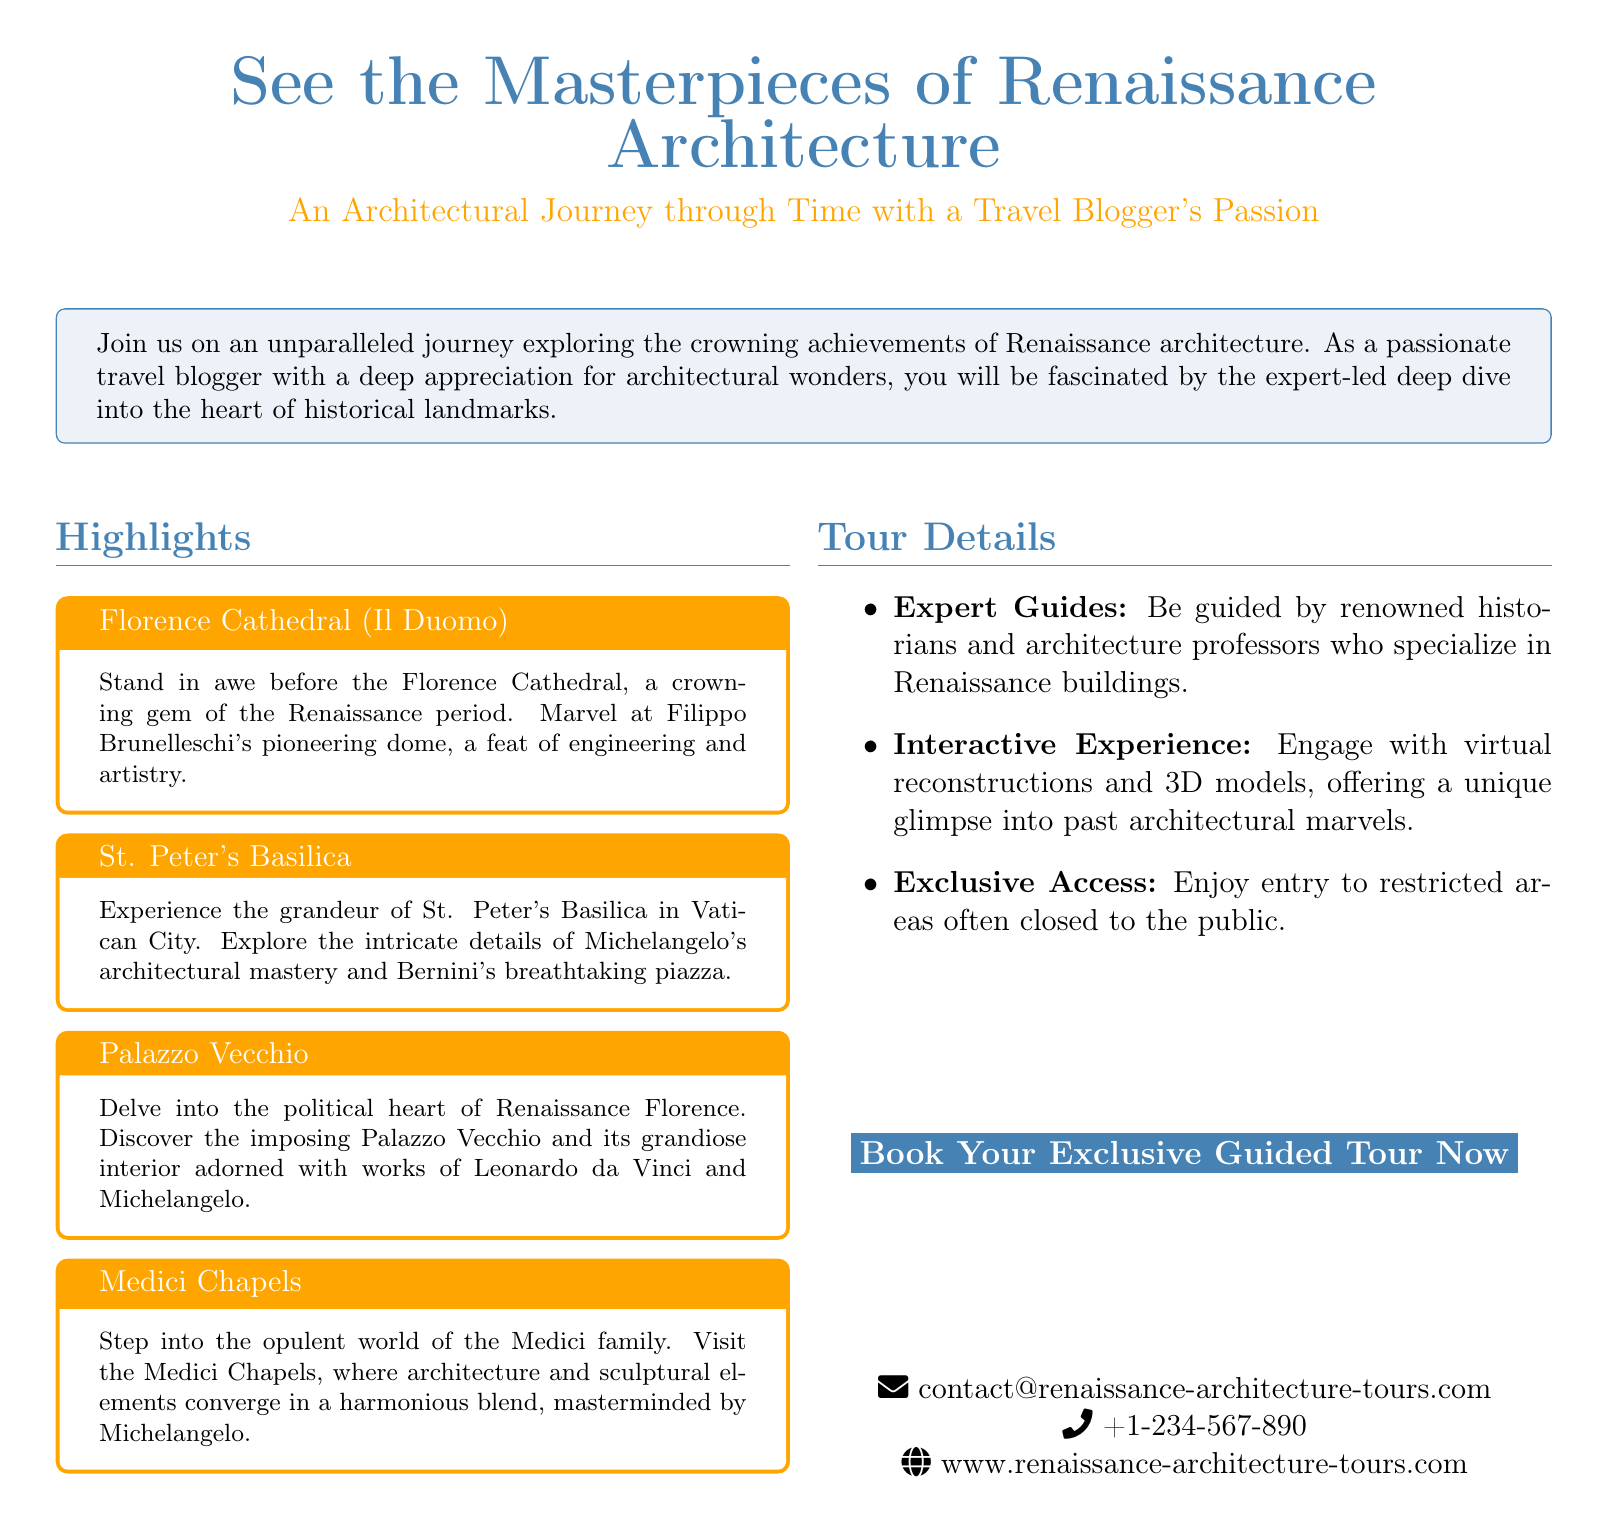What is the title of the event? The title of the event is prominently displayed at the top of the document.
Answer: See the Masterpieces of Renaissance Architecture What city features the Florence Cathedral? The Florence Cathedral is a key highlight mentioned in the document.
Answer: Florence Who designed the dome of the Florence Cathedral? The document attributes the design of the dome to a specific architect.
Answer: Filippo Brunelleschi Which basilica is described in the document? The document specifically names a notable basilica and its location.
Answer: St. Peter's Basilica What is the contact phone number? The document includes a contact number at the bottom.
Answer: +1-234-567-890 What type of experience does the tour offer? The document describes the nature of the tour experience provided.
Answer: Interactive Experience What is featured at the Medici Chapels? The document specifies a unique aspect found at the Medici Chapels.
Answer: Sculpture elements Who guides the tour? The document mentions the type of specialists leading the tours.
Answer: Historians and architecture professors What is one feature of the Palazzo Vecchio? The document highlights a notable aspect of the Palazzo Vecchio's interior.
Answer: Works of Leonardo da Vinci and Michelangelo 